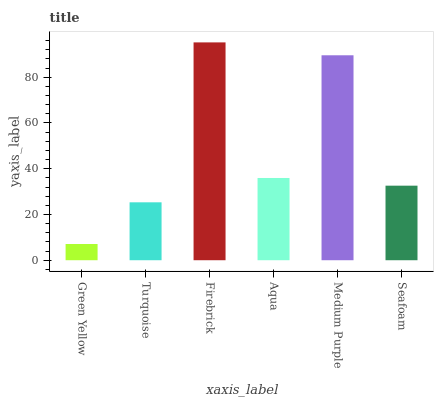Is Green Yellow the minimum?
Answer yes or no. Yes. Is Firebrick the maximum?
Answer yes or no. Yes. Is Turquoise the minimum?
Answer yes or no. No. Is Turquoise the maximum?
Answer yes or no. No. Is Turquoise greater than Green Yellow?
Answer yes or no. Yes. Is Green Yellow less than Turquoise?
Answer yes or no. Yes. Is Green Yellow greater than Turquoise?
Answer yes or no. No. Is Turquoise less than Green Yellow?
Answer yes or no. No. Is Aqua the high median?
Answer yes or no. Yes. Is Seafoam the low median?
Answer yes or no. Yes. Is Medium Purple the high median?
Answer yes or no. No. Is Aqua the low median?
Answer yes or no. No. 